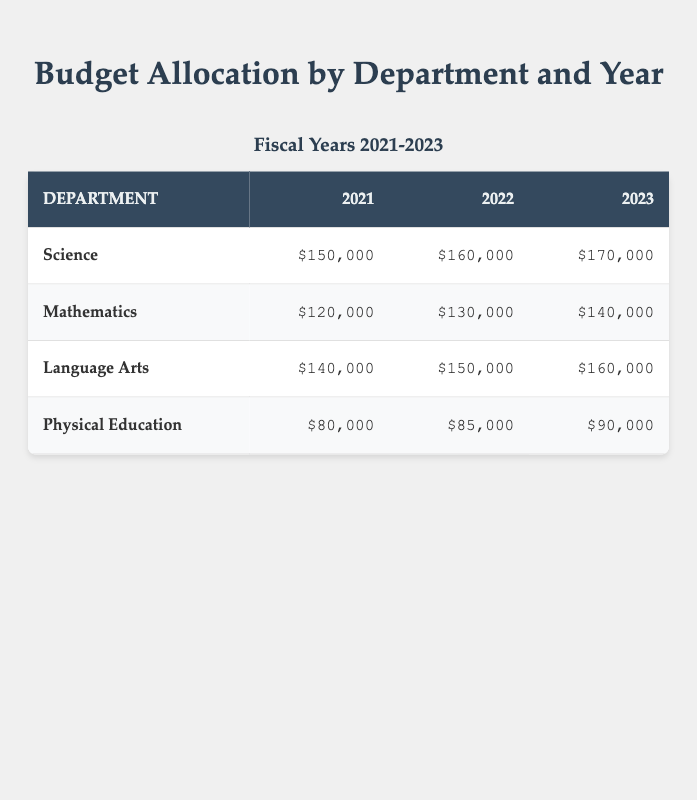What is the budget allocation for the Science department in 2022? The table shows the budget allocation for each department on a year-by-year basis. For the Science department in 2022, the budget allocation is explicitly listed in the corresponding cell.
Answer: 160000 Which department received the highest budget allocation in 2021? To find the department with the highest allocation in 2021, we look at the numbers in that column and identify that Science has the largest allocation of 150000.
Answer: Science What is the total budget allocation for Language Arts over the three years? We sum the budget allocations for Language Arts across all three years: 140000 (2021) + 150000 (2022) + 160000 (2023) = 450000.
Answer: 450000 Is the budget allocation for Physical Education increasing each year? To assess whether there is an increase, we compare the allocations for Physical Education in each year: 80000 (2021), 85000 (2022), and 90000 (2023). Since each allocation is greater than the previous year, it is indeed increasing.
Answer: Yes Which year had the lowest total budget allocation when all departments are considered? We first calculate the total budget allocation for each year: 2021: 150000 + 120000 + 140000 + 80000 = 490000; 2022: 160000 + 130000 + 150000 + 85000 = 525000; 2023: 170000 + 140000 + 160000 + 90000 = 560000. The lowest total is from 2021.
Answer: 2021 